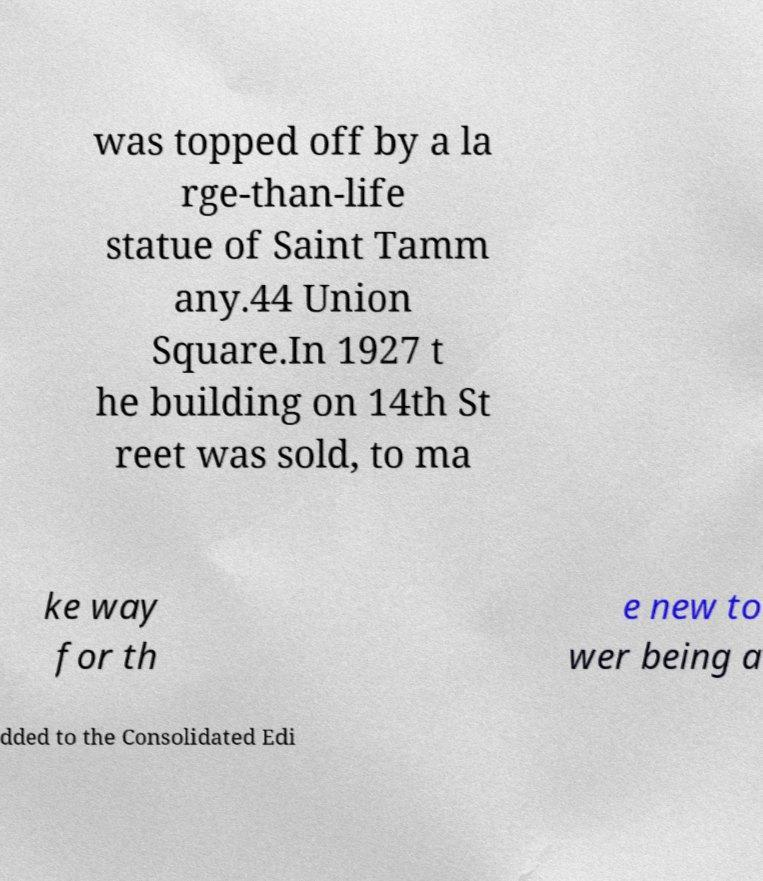There's text embedded in this image that I need extracted. Can you transcribe it verbatim? was topped off by a la rge-than-life statue of Saint Tamm any.44 Union Square.In 1927 t he building on 14th St reet was sold, to ma ke way for th e new to wer being a dded to the Consolidated Edi 